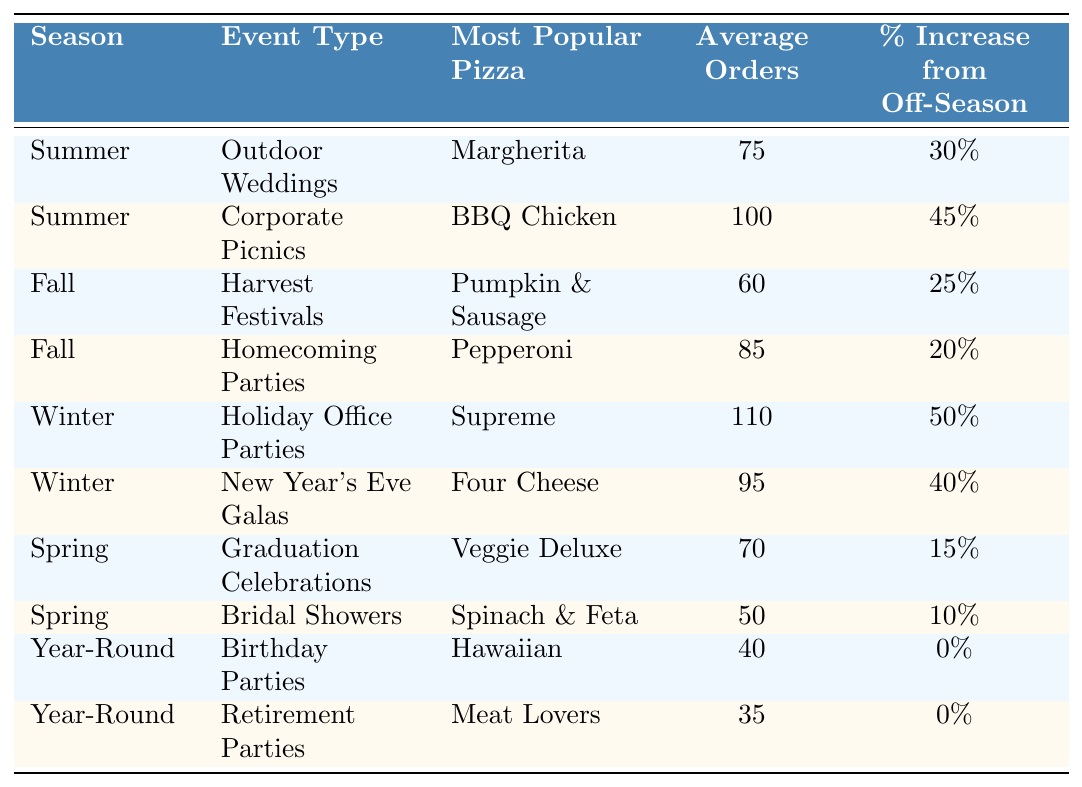What is the most popular pizza for Outdoor Weddings in the Summer? The table clearly indicates that the most popular pizza for Outdoor Weddings during the Summer season is Margherita.
Answer: Margherita How many average orders are there for New Year's Eve Galas in Winter? According to the table, the average orders for New Year's Eve Galas in Winter is 95.
Answer: 95 Which event type has the highest average orders in the Winter season? The table shows that Holiday Office Parties have the highest average orders in Winter, with 110 orders.
Answer: Holiday Office Parties What is the percentage increase in orders from the off-season for Corporate Picnics in Summer? The table lists the percentage increase for Corporate Picnics in Summer as 45%.
Answer: 45% Which season shows the least average orders for its events? By comparing the average orders across seasons, the Spring season shows the least average orders, with Bridal Showers at 50 and Graduation Celebrations at 70, making an average of 60 orders.
Answer: Spring Is the percentage increase in orders for Harvest Festivals greater than that for Homecoming Parties? Comparing the values in the table reveals that Harvest Festivals have a 25% increase while Homecoming Parties have a 20% increase, thus confirming that Harvest Festivals have a greater increase.
Answer: Yes What is the average number of orders for all Year-Round events combined? The average orders for Year-Round events is found by adding the orders for Birthday Parties (40) and Retirement Parties (35), which together total 75. Dividing by 2 gives an average of 37.5.
Answer: 37.5 Which pizza is the most popular for Graduation Celebrations in Spring? The table indicates that the most popular pizza for Graduation Celebrations during the Spring season is Veggie Deluxe.
Answer: Veggie Deluxe How does the average order for Winter events compare to Summer events? The average for Winter events is calculated from Holiday Office Parties (110) and New Year's Eve Galas (95), which gives an average of 102.5. For Summer events, the average from Outdoor Weddings (75) and Corporate Picnics (100) is 87.5. Hence, Winter events have higher average orders.
Answer: Winter events are higher If I want to order the largest quantity of pizza, which event type and season should I choose? The table indicates that Holiday Office Parties in Winter have the highest average orders at 110. Therefore, this would be the best option for ordering the largest quantity.
Answer: Holiday Office Parties in Winter 